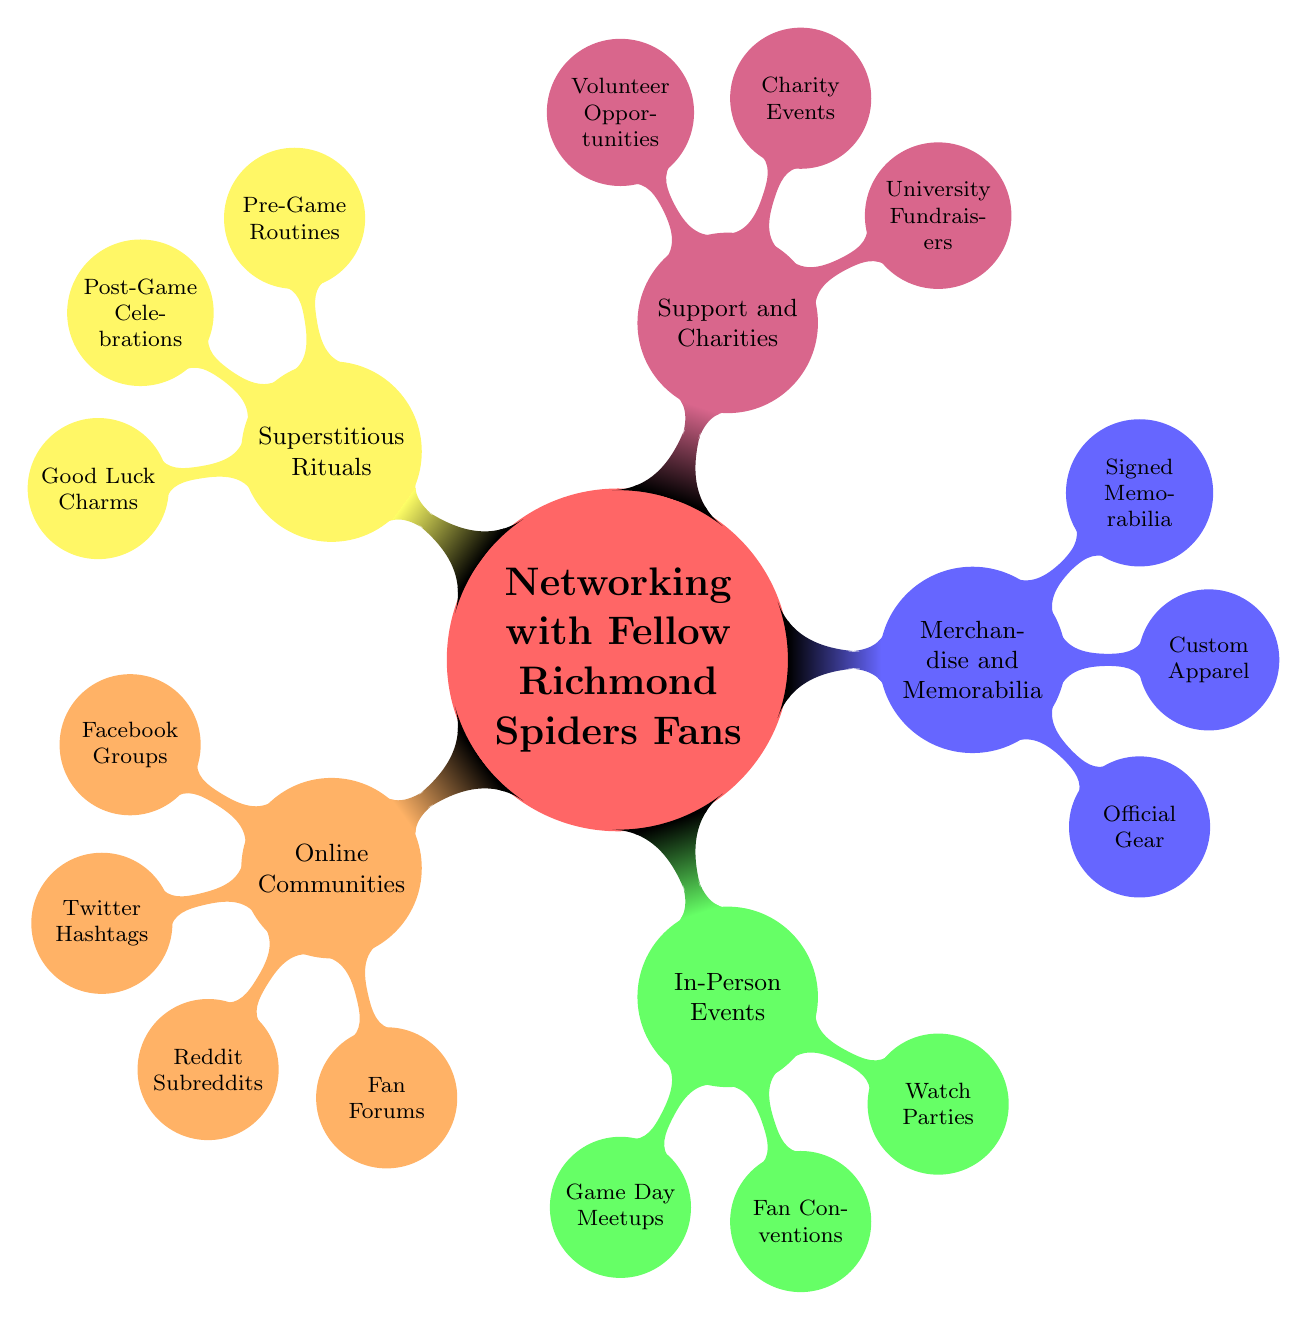What are the online communities available for Richmond Spiders fans? The main node "Online Communities" branches out into four specific communities: "Facebook Groups," "Twitter Hashtags," "Reddit Subreddits," and "Fan Forums."
Answer: Facebook Groups, Twitter Hashtags, Reddit Subreddits, Fan Forums How many categories of networking are shown in the diagram? The main node "Networking with Fellow Richmond Spiders Fans" has five branches indicating five categories: "Online Communities," "In-Person Events," "Merchandise and Memorabilia," "Support and Charities," and "Superstitious Rituals."
Answer: Five Which in-person event is specifically for home games? Under the "In-Person Events" category, the subcategory "Game Day Meetups" specifies "Home Games," which indicates where fans can meet on game day.
Answer: Robins Stadium Tailgate What type of merchandise includes "Custom Apparel"? The node "Custom Apparel" falls under the "Merchandise and Memorabilia" category, indicating it is focused on various merchandise options for fans.
Answer: Merchandise and Memorabilia What is one pre-game ritual Richmond Spiders fans participate in? Under the "Superstitious Rituals" category, the specific node titled "Pre-Game Routines" includes the ritual "Lucky Hat Ceremony," which fans might use to invoke good luck before a game.
Answer: Lucky Hat Ceremony Which charity event is mentioned for Richmond Spiders support? In the "Support and Charities" section, "Charity Events" leads to the specific event "Spider Run for Charity 5K," indicating an avenue for fans to support charitable causes.
Answer: Spider Run for Charity 5K How does "Volunteer Opportunities" relate to the Richmond Spiders? The "Volunteer Opportunities" node under "Support and Charities" indicates ways fans can engage with the community, specifically through community service efforts associated with the Richmond Spiders.
Answer: Community Service with Spiders Which online platform has the hashtag “#SpiderPride”? The "Twitter Hashtags" node specifically contains "#SpiderPride," designating Twitter as the platform where this hashtag can be used to connect with fellow fans.
Answer: #SpiderPride 